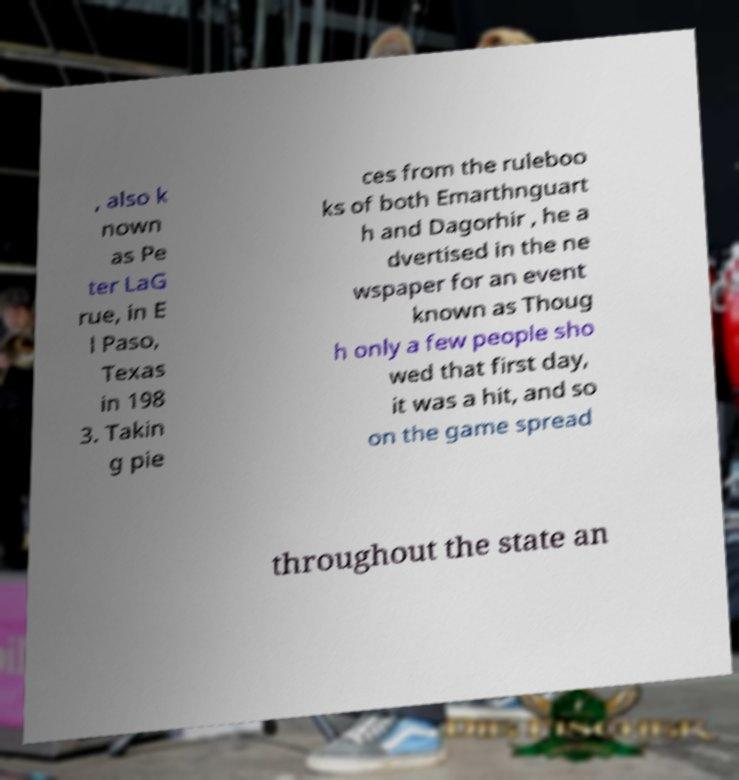Could you assist in decoding the text presented in this image and type it out clearly? , also k nown as Pe ter LaG rue, in E l Paso, Texas in 198 3. Takin g pie ces from the ruleboo ks of both Emarthnguart h and Dagorhir , he a dvertised in the ne wspaper for an event known as Thoug h only a few people sho wed that first day, it was a hit, and so on the game spread throughout the state an 